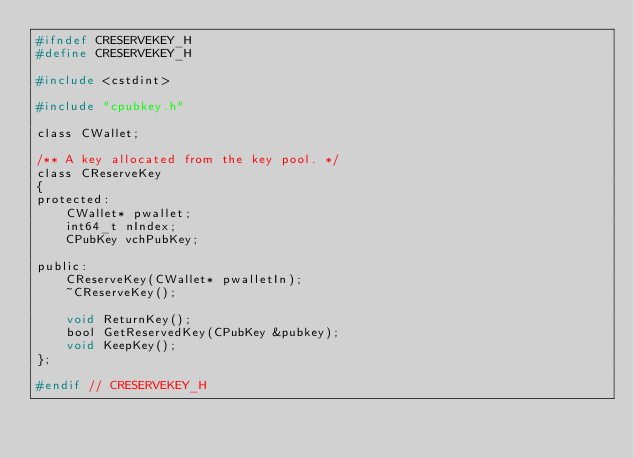Convert code to text. <code><loc_0><loc_0><loc_500><loc_500><_C_>#ifndef CRESERVEKEY_H
#define CRESERVEKEY_H

#include <cstdint>

#include "cpubkey.h"

class CWallet;

/** A key allocated from the key pool. */
class CReserveKey
{
protected:
    CWallet* pwallet;
    int64_t nIndex;
    CPubKey vchPubKey;

public:
    CReserveKey(CWallet* pwalletIn);
    ~CReserveKey();
	
    void ReturnKey();
    bool GetReservedKey(CPubKey &pubkey);
    void KeepKey();
};

#endif // CRESERVEKEY_H
</code> 